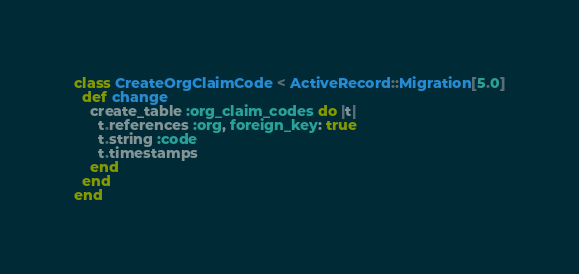Convert code to text. <code><loc_0><loc_0><loc_500><loc_500><_Ruby_>class CreateOrgClaimCode < ActiveRecord::Migration[5.0]
  def change
    create_table :org_claim_codes do |t|
      t.references :org, foreign_key: true
      t.string :code
      t.timestamps
    end
  end
end
</code> 